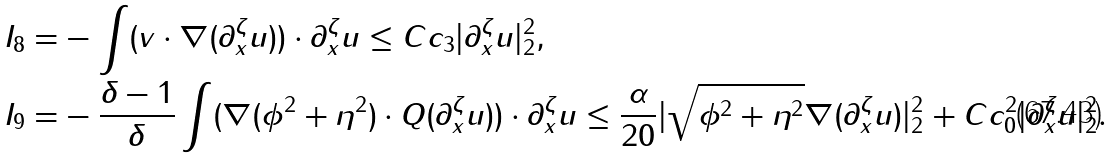Convert formula to latex. <formula><loc_0><loc_0><loc_500><loc_500>I _ { 8 } = & - \int ( v \cdot \nabla ( \partial ^ { \zeta } _ { x } u ) ) \cdot \partial ^ { \zeta } _ { x } u \leq C c _ { 3 } | \partial ^ { \zeta } _ { x } u | ^ { 2 } _ { 2 } , \\ I _ { 9 } = & - \frac { \delta - 1 } { \delta } \int ( \nabla ( \phi ^ { 2 } + \eta ^ { 2 } ) \cdot Q ( \partial ^ { \zeta } _ { x } u ) ) \cdot \partial ^ { \zeta } _ { x } u \leq \frac { \alpha } { 2 0 } | \sqrt { \phi ^ { 2 } + \eta ^ { 2 } } \nabla ( \partial ^ { \zeta } _ { x } u ) | ^ { 2 } _ { 2 } + C c ^ { 2 } _ { 0 } | \partial ^ { \zeta } _ { x } u | ^ { 2 } _ { 2 } .</formula> 